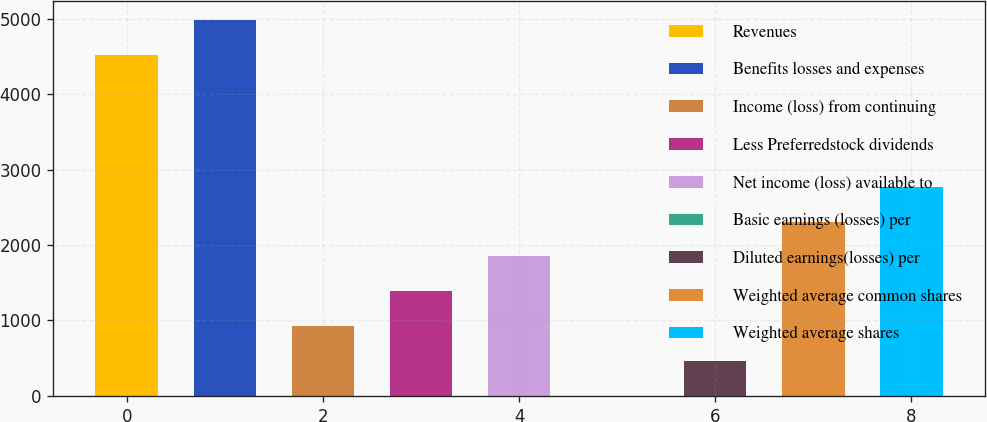Convert chart to OTSL. <chart><loc_0><loc_0><loc_500><loc_500><bar_chart><fcel>Revenues<fcel>Benefits losses and expenses<fcel>Income (loss) from continuing<fcel>Less Preferredstock dividends<fcel>Net income (loss) available to<fcel>Basic earnings (losses) per<fcel>Diluted earnings(losses) per<fcel>Weighted average common shares<fcel>Weighted average shares<nl><fcel>4520<fcel>4982.4<fcel>924.82<fcel>1387.22<fcel>1849.62<fcel>0.02<fcel>462.42<fcel>2312.02<fcel>2774.42<nl></chart> 